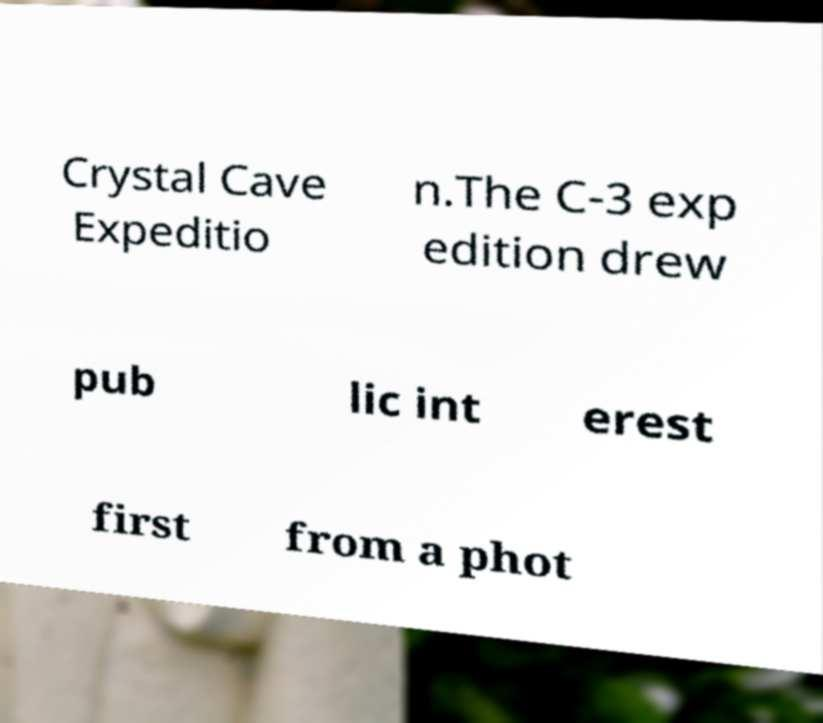Please identify and transcribe the text found in this image. Crystal Cave Expeditio n.The C-3 exp edition drew pub lic int erest first from a phot 